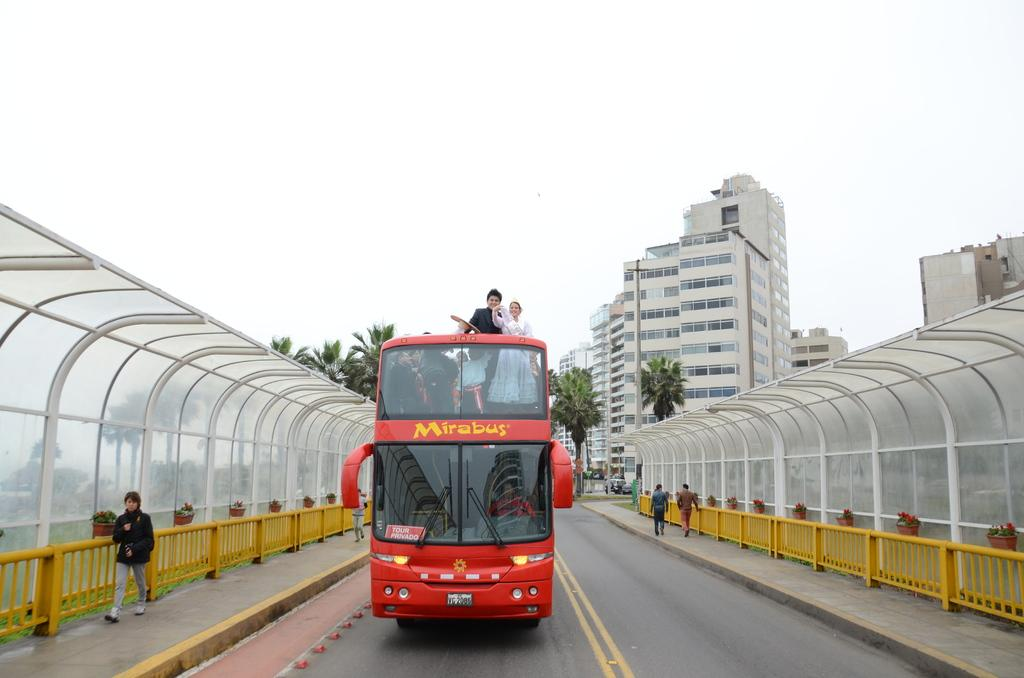<image>
Present a compact description of the photo's key features. A large red bus with the word Mirabus on it 